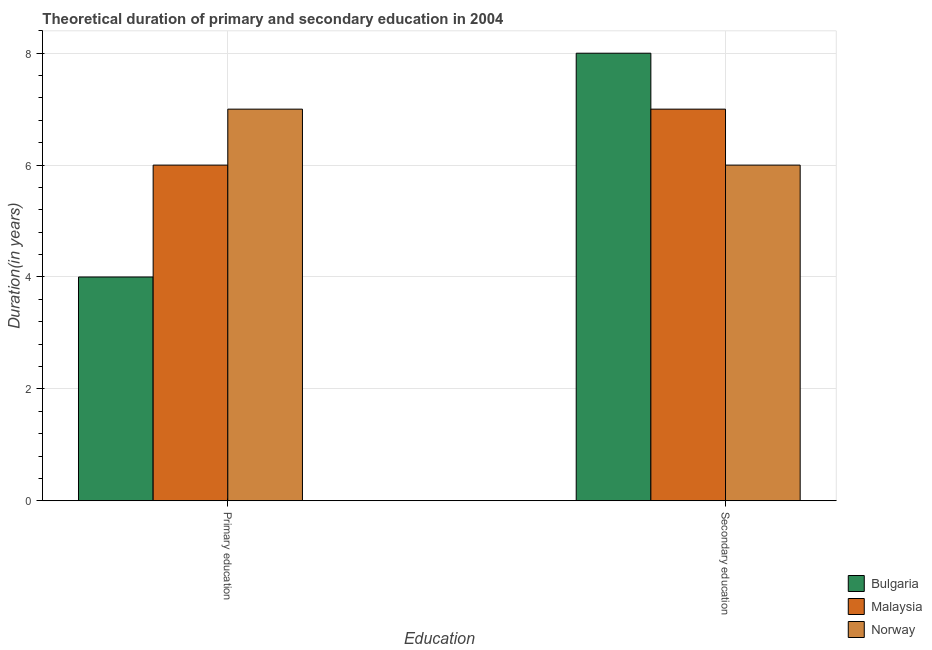How many different coloured bars are there?
Provide a short and direct response. 3. Are the number of bars on each tick of the X-axis equal?
Offer a terse response. Yes. How many bars are there on the 1st tick from the left?
Provide a succinct answer. 3. How many bars are there on the 1st tick from the right?
Offer a terse response. 3. What is the duration of primary education in Bulgaria?
Offer a very short reply. 4. Across all countries, what is the maximum duration of primary education?
Your answer should be compact. 7. Across all countries, what is the minimum duration of primary education?
Provide a short and direct response. 4. In which country was the duration of secondary education minimum?
Offer a terse response. Norway. What is the total duration of secondary education in the graph?
Offer a very short reply. 21. What is the difference between the duration of primary education in Malaysia and that in Norway?
Your answer should be very brief. -1. What is the average duration of secondary education per country?
Ensure brevity in your answer.  7. What is the difference between the duration of primary education and duration of secondary education in Norway?
Ensure brevity in your answer.  1. In how many countries, is the duration of secondary education greater than 6.4 years?
Your response must be concise. 2. What is the ratio of the duration of primary education in Bulgaria to that in Norway?
Make the answer very short. 0.57. In how many countries, is the duration of secondary education greater than the average duration of secondary education taken over all countries?
Ensure brevity in your answer.  1. What does the 2nd bar from the right in Primary education represents?
Your response must be concise. Malaysia. How many bars are there?
Provide a short and direct response. 6. Are all the bars in the graph horizontal?
Your answer should be very brief. No. Does the graph contain grids?
Keep it short and to the point. Yes. Where does the legend appear in the graph?
Your answer should be very brief. Bottom right. How many legend labels are there?
Your answer should be very brief. 3. What is the title of the graph?
Ensure brevity in your answer.  Theoretical duration of primary and secondary education in 2004. Does "Bhutan" appear as one of the legend labels in the graph?
Keep it short and to the point. No. What is the label or title of the X-axis?
Offer a very short reply. Education. What is the label or title of the Y-axis?
Provide a short and direct response. Duration(in years). What is the Duration(in years) in Norway in Primary education?
Provide a short and direct response. 7. What is the Duration(in years) of Bulgaria in Secondary education?
Keep it short and to the point. 8. What is the Duration(in years) in Norway in Secondary education?
Keep it short and to the point. 6. Across all Education, what is the maximum Duration(in years) in Bulgaria?
Offer a terse response. 8. Across all Education, what is the maximum Duration(in years) of Norway?
Your answer should be compact. 7. Across all Education, what is the minimum Duration(in years) of Malaysia?
Your answer should be very brief. 6. Across all Education, what is the minimum Duration(in years) of Norway?
Ensure brevity in your answer.  6. What is the total Duration(in years) of Norway in the graph?
Give a very brief answer. 13. What is the difference between the Duration(in years) in Bulgaria in Primary education and that in Secondary education?
Give a very brief answer. -4. What is the difference between the Duration(in years) of Malaysia in Primary education and that in Secondary education?
Provide a short and direct response. -1. What is the average Duration(in years) in Bulgaria per Education?
Make the answer very short. 6. What is the average Duration(in years) of Malaysia per Education?
Your answer should be very brief. 6.5. What is the difference between the Duration(in years) of Bulgaria and Duration(in years) of Norway in Primary education?
Your answer should be compact. -3. What is the difference between the Duration(in years) in Malaysia and Duration(in years) in Norway in Primary education?
Provide a succinct answer. -1. What is the difference between the Duration(in years) in Bulgaria and Duration(in years) in Norway in Secondary education?
Provide a succinct answer. 2. What is the ratio of the Duration(in years) in Bulgaria in Primary education to that in Secondary education?
Keep it short and to the point. 0.5. What is the difference between the highest and the second highest Duration(in years) in Norway?
Keep it short and to the point. 1. 